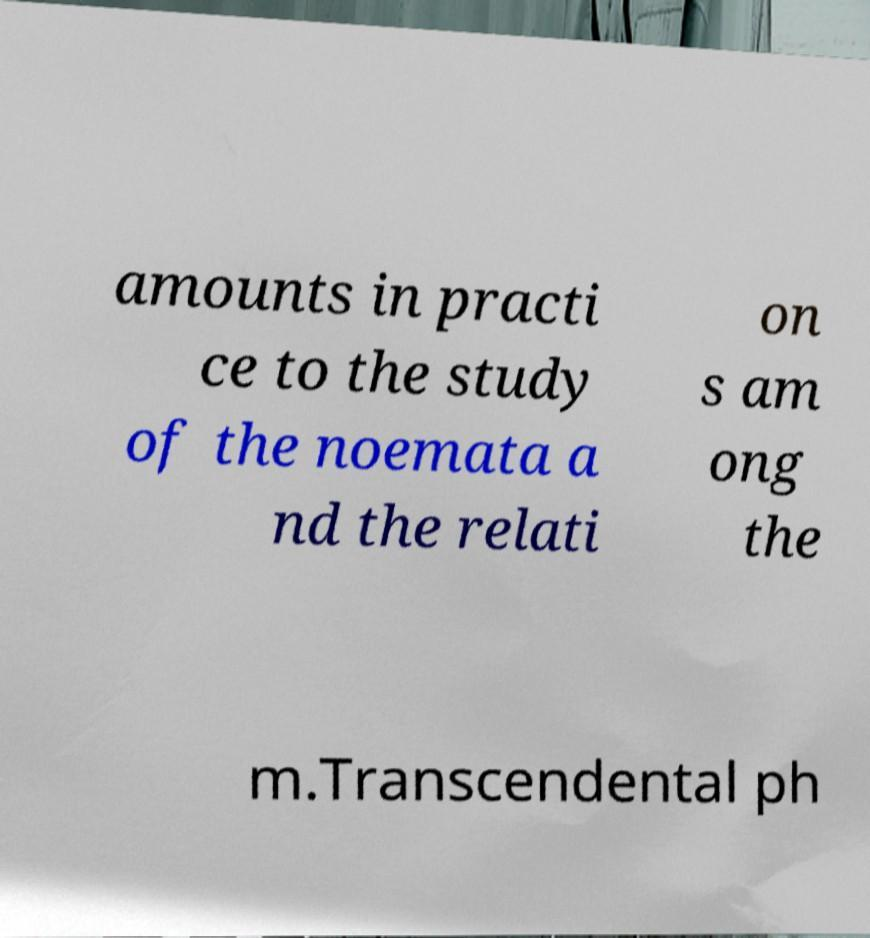Can you read and provide the text displayed in the image?This photo seems to have some interesting text. Can you extract and type it out for me? amounts in practi ce to the study of the noemata a nd the relati on s am ong the m.Transcendental ph 